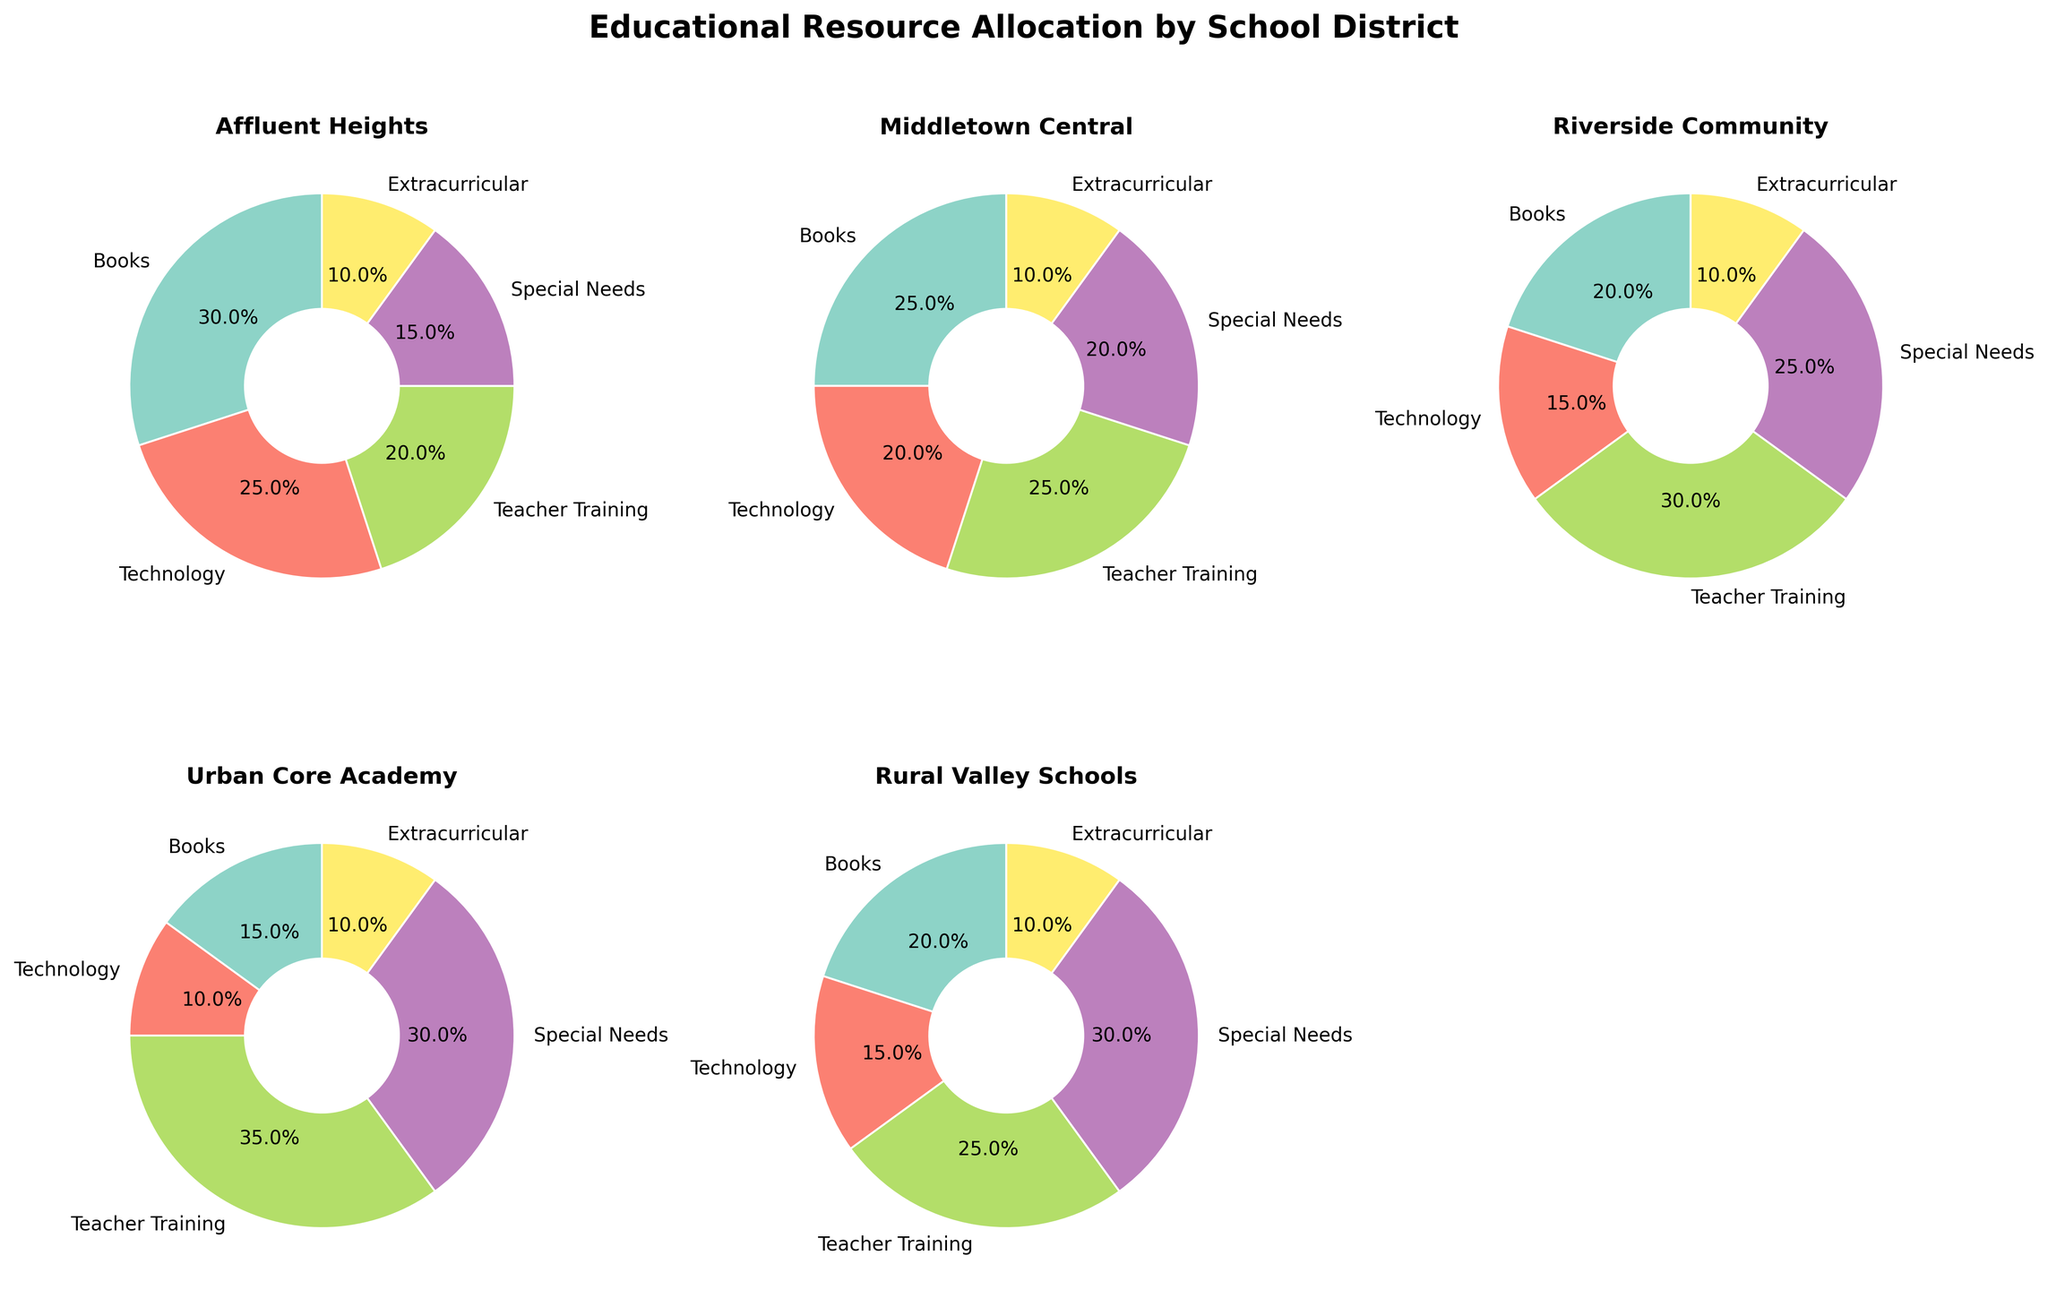What's the title of the figure? The title of the figure is typically shown at the top and provides an overview of the plot, indicating the main subject or the focus of the visualization. In this case, the title is given in the code snippet.
Answer: Educational Resource Allocation by School District Which school district allocates the highest percentage to Teacher Training? To determine the highest allocation for Teacher Training, look for the largest slice labeled "Teacher Training" across all the pie charts. The Urban Core Academy pie chart has the biggest Teacher Training slice at 35%.
Answer: Urban Core Academy What is the total percentage allocation to Books in Middletown Central and Riverside Community combined? First, find the percentage of Books in both Middletown Central (25%) and Riverside Community (20%). Then, add these percentages: 25% + 20% = 45%.
Answer: 45% What resource has the smallest allocation across all school districts? In each pie chart, find the smallest percentage allocated. All districts show an allocation of 10% for Extracurricular, which is the lowest across all categories.
Answer: Extracurricular Compare the allocation to Special Needs between Urban Core Academy and Rural Valley Schools. Which allocates more and by how much? Urban Core Academy allocates 30% to Special Needs, while Rural Valley Schools allocates the same amount, 30%. Therefore, the difference is zero.
Answer: Neither, the allocation is the same What is the combined percentage allocation to Technology in Affluent Heights and Urban Core Academy? Affluent Heights allocates 25% to Technology, and Urban Core Academy allocates 10%. Combined, this is 25% + 10% = 35%.
Answer: 35% Which school district allocates the highest percentage to Books? Compare the Books slice across all school districts. Affluent Heights has the largest slice at 30%.
Answer: Affluent Heights How does the percentage allocation to Special Needs change from Affluent Heights to Urban Core Academy? Affluent Heights allocates 15% to Special Needs, while Urban Core Academy allocates 30%. The increase is 30% - 15% = 15%.
Answer: Increases by 15% What is the total percentage allocation to Teacher Training and Special Needs in Riverside Community? Riverside Community allocates 30% to Teacher Training and 25% to Special Needs. The total is 30% + 25% = 55%.
Answer: 55% Which school district has the most balanced distribution of resources? Explain briefly. The most balanced distribution would have similar-sized slices for different resources. Riverside Community looks fairly balanced with no extremely large or small slices compared to other districts.
Answer: Riverside Community 